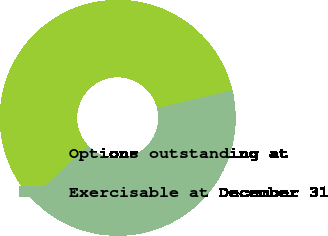Convert chart. <chart><loc_0><loc_0><loc_500><loc_500><pie_chart><fcel>Options outstanding at<fcel>Exercisable at December 31<nl><fcel>58.21%<fcel>41.79%<nl></chart> 